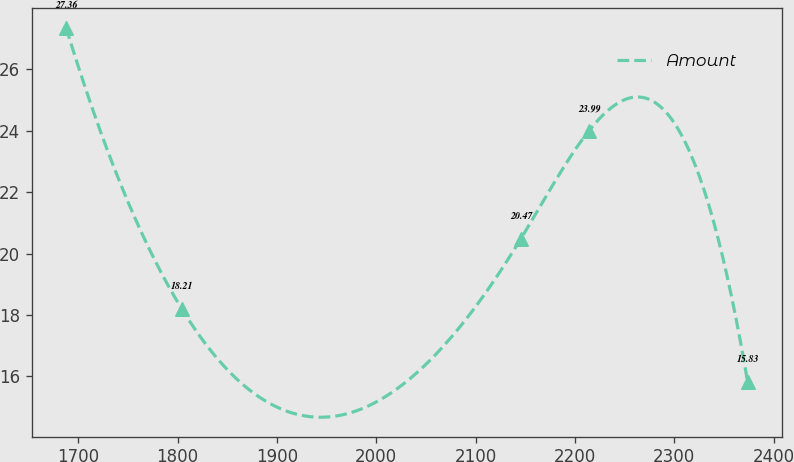Convert chart to OTSL. <chart><loc_0><loc_0><loc_500><loc_500><line_chart><ecel><fcel>Amount<nl><fcel>1687.7<fcel>27.36<nl><fcel>1804.02<fcel>18.21<nl><fcel>2145.35<fcel>20.47<nl><fcel>2213.97<fcel>23.99<nl><fcel>2373.87<fcel>15.83<nl></chart> 